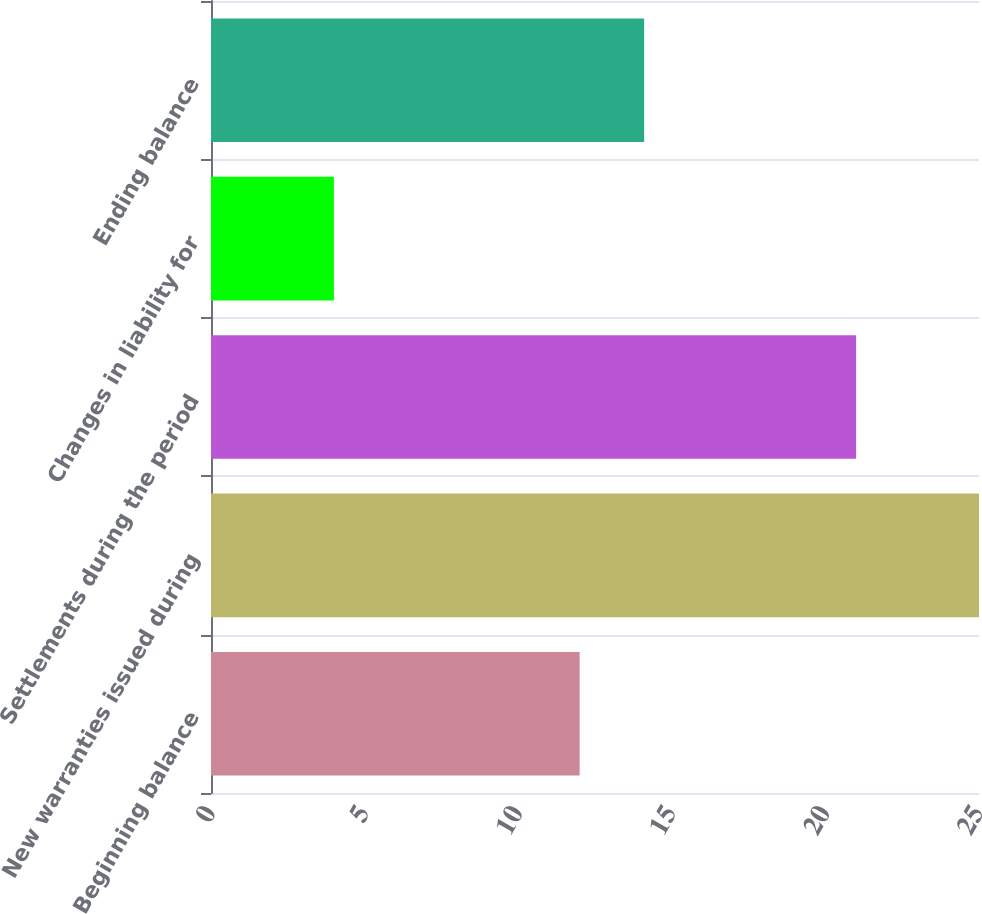Convert chart. <chart><loc_0><loc_0><loc_500><loc_500><bar_chart><fcel>Beginning balance<fcel>New warranties issued during<fcel>Settlements during the period<fcel>Changes in liability for<fcel>Ending balance<nl><fcel>12<fcel>25<fcel>21<fcel>4<fcel>14.1<nl></chart> 